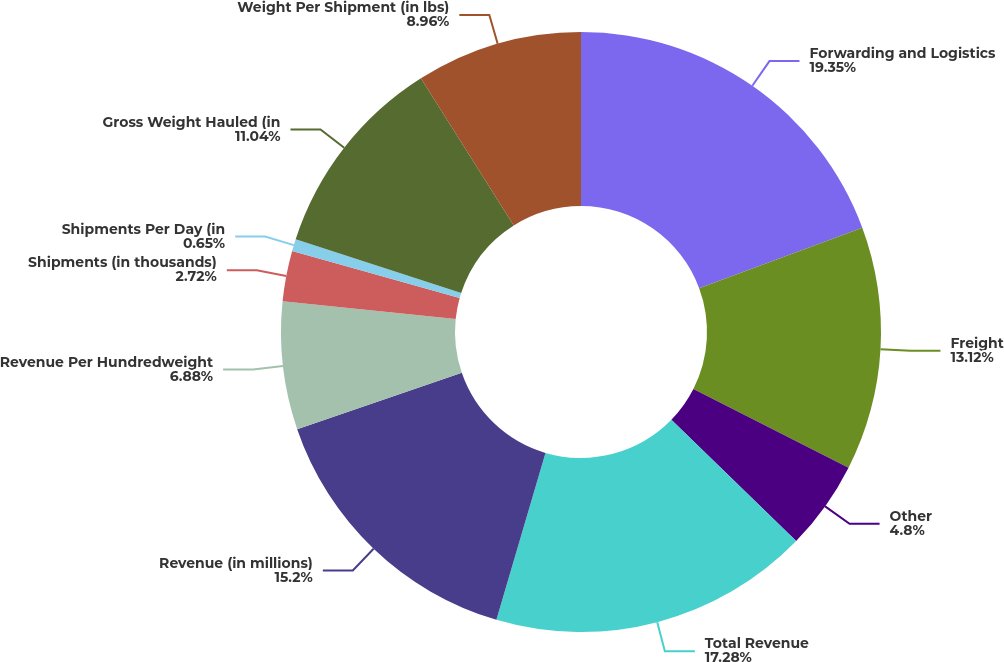<chart> <loc_0><loc_0><loc_500><loc_500><pie_chart><fcel>Forwarding and Logistics<fcel>Freight<fcel>Other<fcel>Total Revenue<fcel>Revenue (in millions)<fcel>Revenue Per Hundredweight<fcel>Shipments (in thousands)<fcel>Shipments Per Day (in<fcel>Gross Weight Hauled (in<fcel>Weight Per Shipment (in lbs)<nl><fcel>19.35%<fcel>13.12%<fcel>4.8%<fcel>17.28%<fcel>15.2%<fcel>6.88%<fcel>2.72%<fcel>0.65%<fcel>11.04%<fcel>8.96%<nl></chart> 